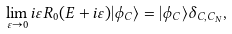Convert formula to latex. <formula><loc_0><loc_0><loc_500><loc_500>\lim _ { \varepsilon \rightarrow 0 } i \varepsilon { R } _ { 0 } ( E + i \varepsilon ) | \phi _ { C } \rangle = | \phi _ { C } \rangle \delta _ { C , C _ { N } } ,</formula> 